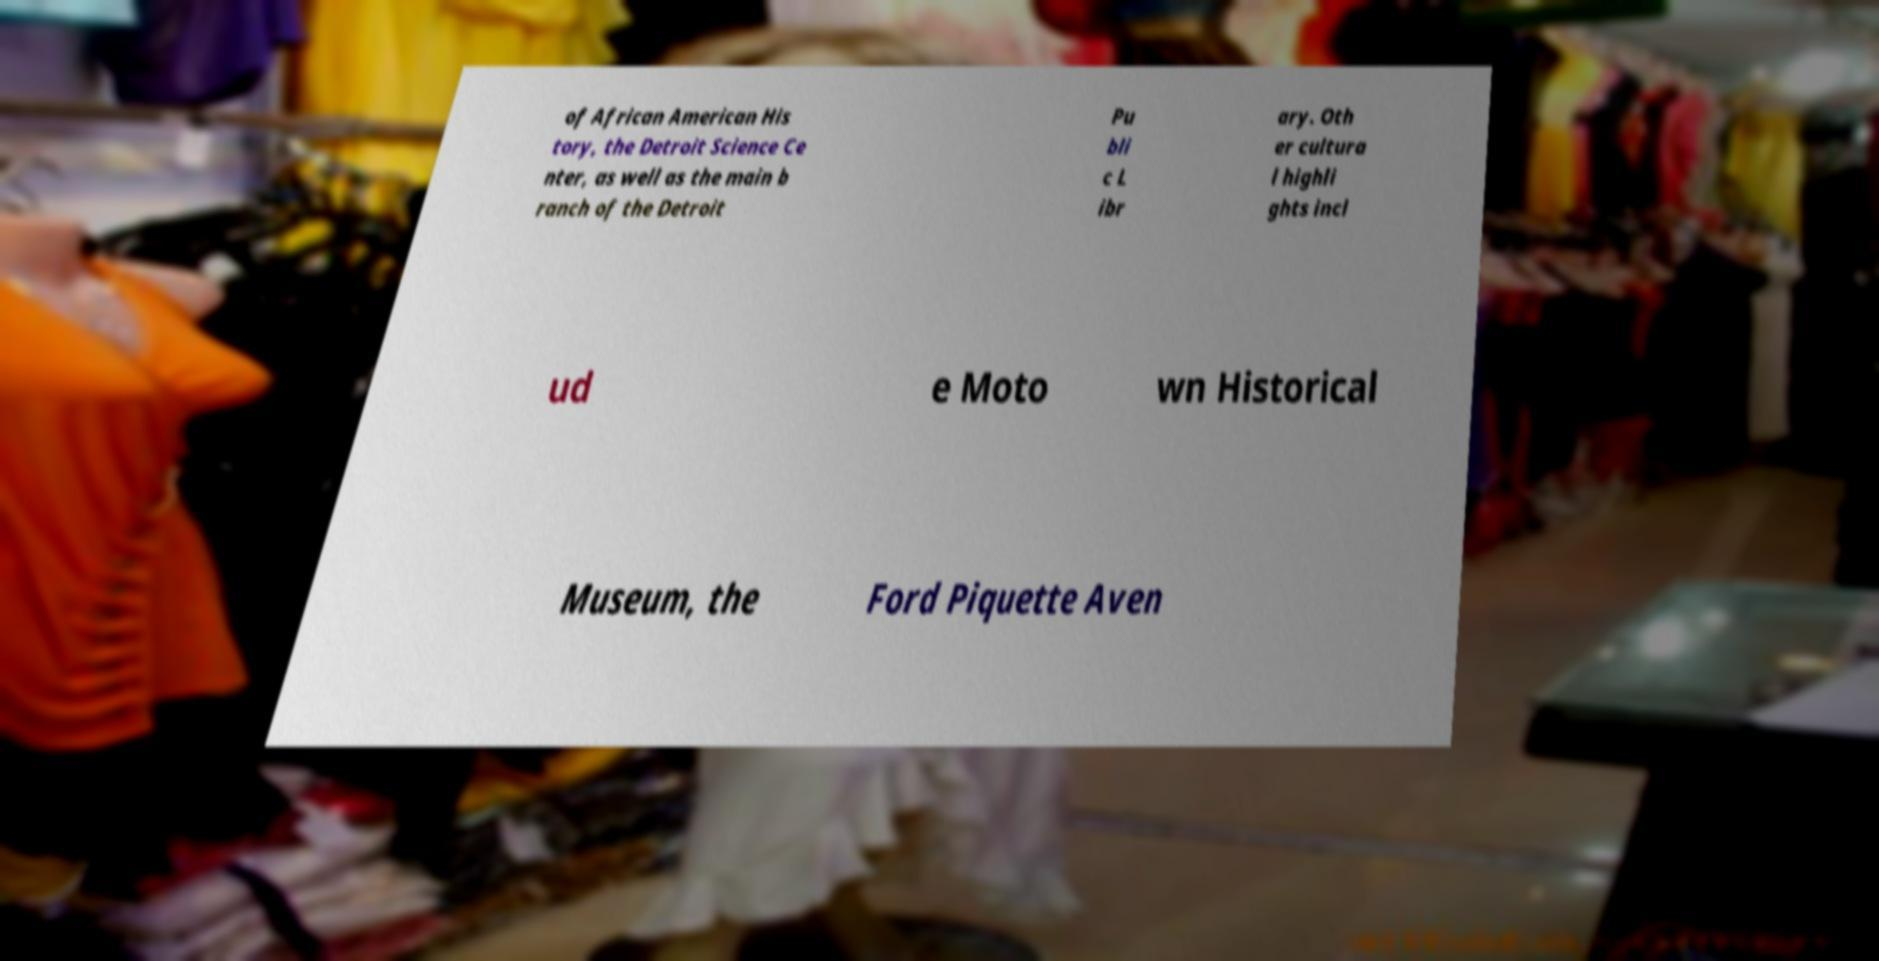Could you assist in decoding the text presented in this image and type it out clearly? of African American His tory, the Detroit Science Ce nter, as well as the main b ranch of the Detroit Pu bli c L ibr ary. Oth er cultura l highli ghts incl ud e Moto wn Historical Museum, the Ford Piquette Aven 